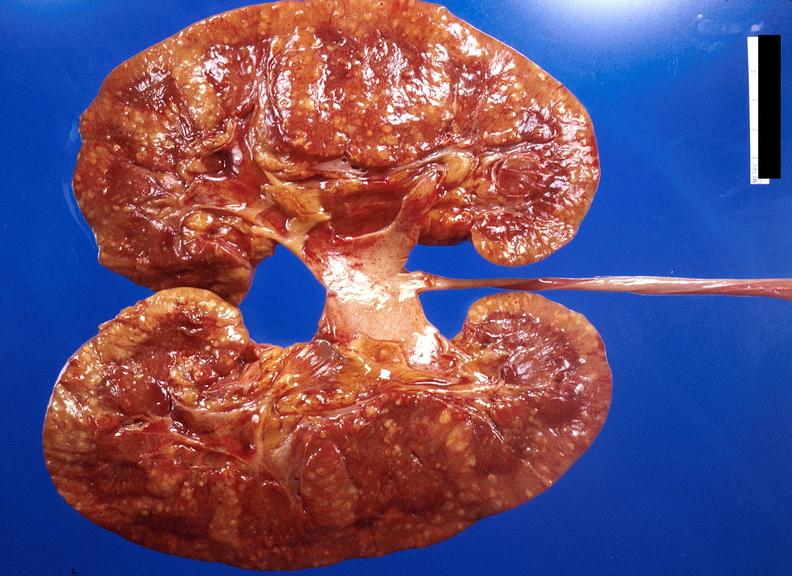does palpable purpura with desquamation show kidney, candida abscesses?
Answer the question using a single word or phrase. No 